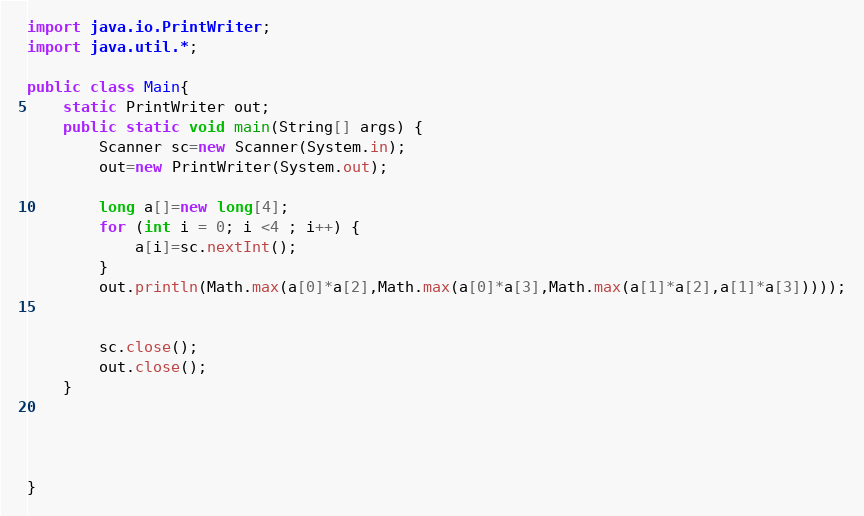<code> <loc_0><loc_0><loc_500><loc_500><_Java_>import java.io.PrintWriter;
import java.util.*;

public class Main{
    static PrintWriter out;
    public static void main(String[] args) {
        Scanner sc=new Scanner(System.in);
        out=new PrintWriter(System.out);

        long a[]=new long[4];
        for (int i = 0; i <4 ; i++) {
            a[i]=sc.nextInt();
        }
        out.println(Math.max(a[0]*a[2],Math.max(a[0]*a[3],Math.max(a[1]*a[2],a[1]*a[3]))));


        sc.close();
        out.close();
    }




}</code> 